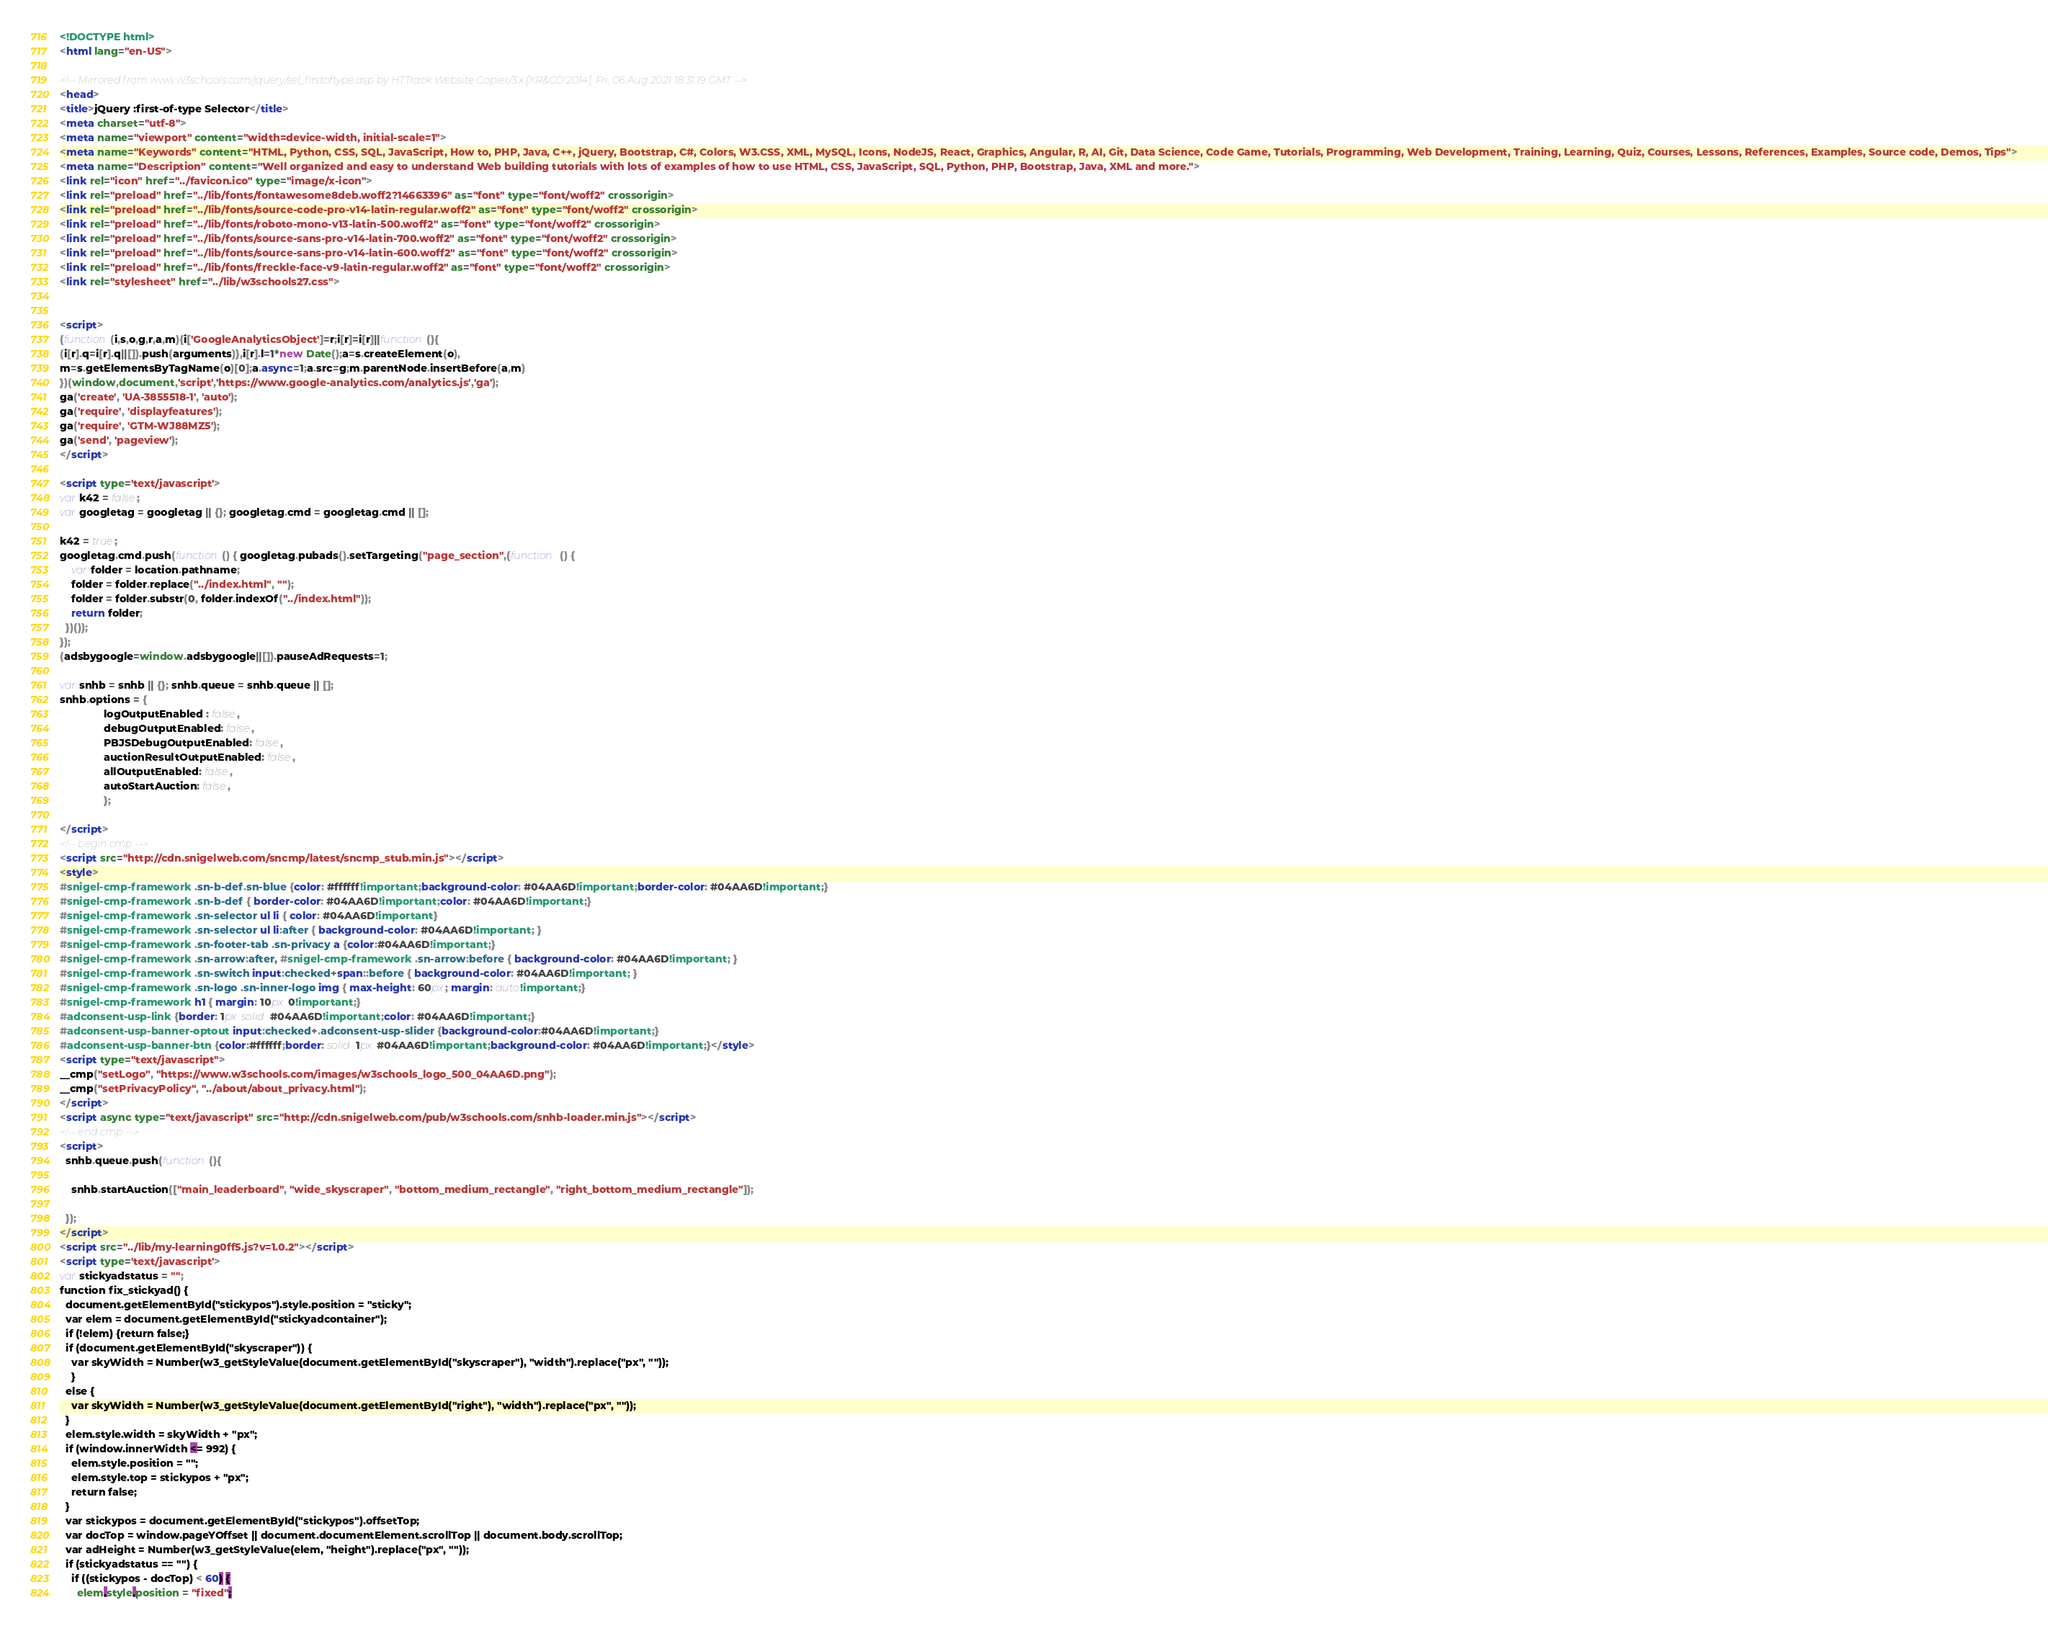Convert code to text. <code><loc_0><loc_0><loc_500><loc_500><_HTML_>
<!DOCTYPE html>
<html lang="en-US">

<!-- Mirrored from www.w3schools.com/jquery/sel_firstoftype.asp by HTTrack Website Copier/3.x [XR&CO'2014], Fri, 06 Aug 2021 18:31:19 GMT -->
<head>
<title>jQuery :first-of-type Selector</title>
<meta charset="utf-8">
<meta name="viewport" content="width=device-width, initial-scale=1">
<meta name="Keywords" content="HTML, Python, CSS, SQL, JavaScript, How to, PHP, Java, C++, jQuery, Bootstrap, C#, Colors, W3.CSS, XML, MySQL, Icons, NodeJS, React, Graphics, Angular, R, AI, Git, Data Science, Code Game, Tutorials, Programming, Web Development, Training, Learning, Quiz, Courses, Lessons, References, Examples, Source code, Demos, Tips">
<meta name="Description" content="Well organized and easy to understand Web building tutorials with lots of examples of how to use HTML, CSS, JavaScript, SQL, Python, PHP, Bootstrap, Java, XML and more.">
<link rel="icon" href="../favicon.ico" type="image/x-icon">
<link rel="preload" href="../lib/fonts/fontawesome8deb.woff2?14663396" as="font" type="font/woff2" crossorigin> 
<link rel="preload" href="../lib/fonts/source-code-pro-v14-latin-regular.woff2" as="font" type="font/woff2" crossorigin> 
<link rel="preload" href="../lib/fonts/roboto-mono-v13-latin-500.woff2" as="font" type="font/woff2" crossorigin> 
<link rel="preload" href="../lib/fonts/source-sans-pro-v14-latin-700.woff2" as="font" type="font/woff2" crossorigin> 
<link rel="preload" href="../lib/fonts/source-sans-pro-v14-latin-600.woff2" as="font" type="font/woff2" crossorigin> 
<link rel="preload" href="../lib/fonts/freckle-face-v9-latin-regular.woff2" as="font" type="font/woff2" crossorigin> 
<link rel="stylesheet" href="../lib/w3schools27.css">


<script>
(function(i,s,o,g,r,a,m){i['GoogleAnalyticsObject']=r;i[r]=i[r]||function(){
(i[r].q=i[r].q||[]).push(arguments)},i[r].l=1*new Date();a=s.createElement(o),
m=s.getElementsByTagName(o)[0];a.async=1;a.src=g;m.parentNode.insertBefore(a,m)
})(window,document,'script','https://www.google-analytics.com/analytics.js','ga');
ga('create', 'UA-3855518-1', 'auto');
ga('require', 'displayfeatures');
ga('require', 'GTM-WJ88MZ5');
ga('send', 'pageview');
</script>

<script type='text/javascript'>
var k42 = false;
var googletag = googletag || {}; googletag.cmd = googletag.cmd || [];

k42 = true;
googletag.cmd.push(function() { googletag.pubads().setTargeting("page_section",(function () {
    var folder = location.pathname;
    folder = folder.replace("../index.html", "");
    folder = folder.substr(0, folder.indexOf("../index.html"));
    return folder;
  })());
});  
(adsbygoogle=window.adsbygoogle||[]).pauseAdRequests=1;

var snhb = snhb || {}; snhb.queue = snhb.queue || [];
snhb.options = {
               logOutputEnabled : false,
               debugOutputEnabled: false,
               PBJSDebugOutputEnabled: false,
               auctionResultOutputEnabled: false,
               allOutputEnabled: false,
               autoStartAuction: false,
               };

</script>
<!-- begin cmp -->
<script src="http://cdn.snigelweb.com/sncmp/latest/sncmp_stub.min.js"></script>
<style>
#snigel-cmp-framework .sn-b-def.sn-blue {color: #ffffff!important;background-color: #04AA6D!important;border-color: #04AA6D!important;}
#snigel-cmp-framework .sn-b-def { border-color: #04AA6D!important;color: #04AA6D!important;}
#snigel-cmp-framework .sn-selector ul li { color: #04AA6D!important}
#snigel-cmp-framework .sn-selector ul li:after { background-color: #04AA6D!important; }
#snigel-cmp-framework .sn-footer-tab .sn-privacy a {color:#04AA6D!important;}
#snigel-cmp-framework .sn-arrow:after, #snigel-cmp-framework .sn-arrow:before { background-color: #04AA6D!important; }
#snigel-cmp-framework .sn-switch input:checked+span::before { background-color: #04AA6D!important; }
#snigel-cmp-framework .sn-logo .sn-inner-logo img { max-height: 60px; margin: auto!important;}
#snigel-cmp-framework h1 { margin: 10px 0!important;}
#adconsent-usp-link {border: 1px solid #04AA6D!important;color: #04AA6D!important;}
#adconsent-usp-banner-optout input:checked+.adconsent-usp-slider {background-color:#04AA6D!important;}
#adconsent-usp-banner-btn {color:#ffffff;border: solid 1px #04AA6D!important;background-color: #04AA6D!important;}</style>
<script type="text/javascript">
__cmp("setLogo", "https://www.w3schools.com/images/w3schools_logo_500_04AA6D.png");
__cmp("setPrivacyPolicy", "../about/about_privacy.html");
</script>
<script async type="text/javascript" src="http://cdn.snigelweb.com/pub/w3schools.com/snhb-loader.min.js"></script>
<!-- end cmp -->
<script>
  snhb.queue.push(function(){

    snhb.startAuction(["main_leaderboard", "wide_skyscraper", "bottom_medium_rectangle", "right_bottom_medium_rectangle"]);

  });
</script>
<script src="../lib/my-learning0ff5.js?v=1.0.2"></script>
<script type='text/javascript'>
var stickyadstatus = "";
function fix_stickyad() {
  document.getElementById("stickypos").style.position = "sticky";
  var elem = document.getElementById("stickyadcontainer");
  if (!elem) {return false;}
  if (document.getElementById("skyscraper")) {
    var skyWidth = Number(w3_getStyleValue(document.getElementById("skyscraper"), "width").replace("px", ""));  
    }
  else {
    var skyWidth = Number(w3_getStyleValue(document.getElementById("right"), "width").replace("px", ""));  
  }
  elem.style.width = skyWidth + "px";
  if (window.innerWidth <= 992) {
    elem.style.position = "";
    elem.style.top = stickypos + "px";
    return false;
  }
  var stickypos = document.getElementById("stickypos").offsetTop;
  var docTop = window.pageYOffset || document.documentElement.scrollTop || document.body.scrollTop;
  var adHeight = Number(w3_getStyleValue(elem, "height").replace("px", ""));
  if (stickyadstatus == "") {
    if ((stickypos - docTop) < 60) {
      elem.style.position = "fixed";</code> 